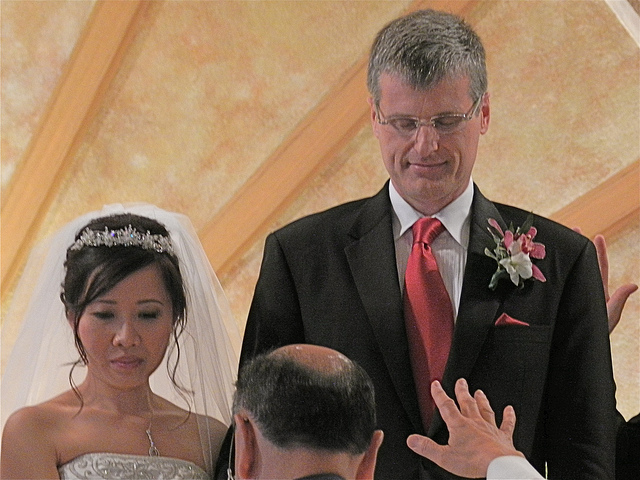<image>What holiday is associated with the headband the girl is wearing? There is no girl in the image wearing a headband. However, it can be associated with a wedding if there were. What holiday is associated with the headband the girl is wearing? I don't know what holiday is associated with the headband the girl is wearing. I can't see any girl in the image. 